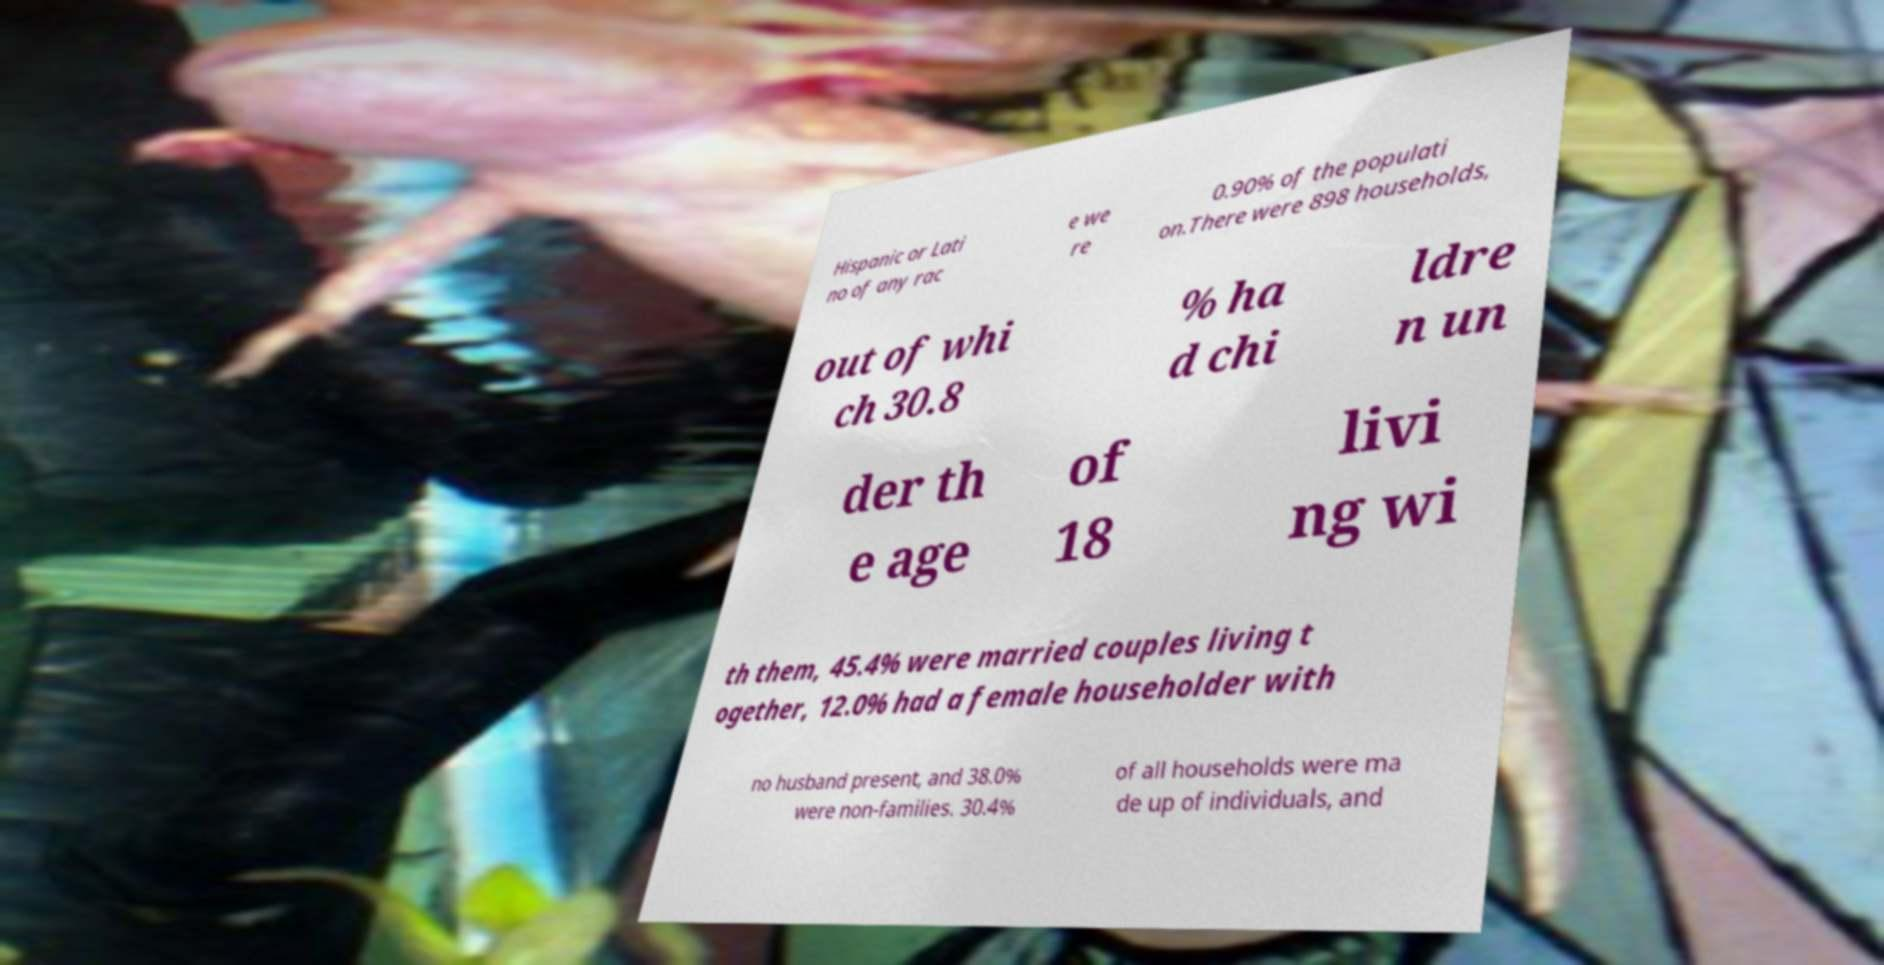I need the written content from this picture converted into text. Can you do that? Hispanic or Lati no of any rac e we re 0.90% of the populati on.There were 898 households, out of whi ch 30.8 % ha d chi ldre n un der th e age of 18 livi ng wi th them, 45.4% were married couples living t ogether, 12.0% had a female householder with no husband present, and 38.0% were non-families. 30.4% of all households were ma de up of individuals, and 